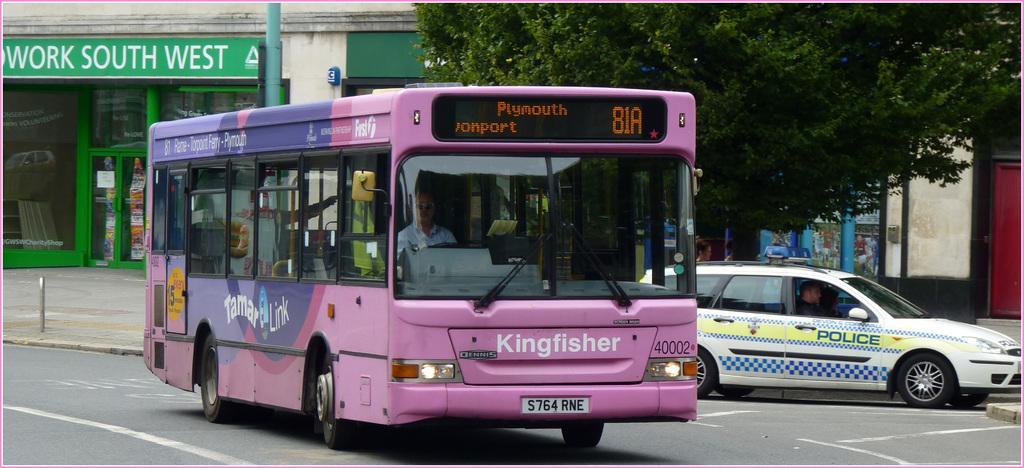How would you summarize this image in a sentence or two? In this image we can see vehicles on the road. In the background there are buildings, poles and trees. 